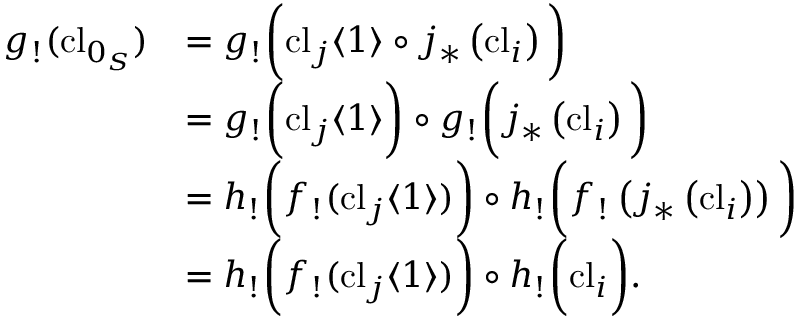Convert formula to latex. <formula><loc_0><loc_0><loc_500><loc_500>\begin{array} { r l } { g _ { ! } ( c l _ { 0 _ { S } } ) } & { = g _ { ! } \left ( c l _ { j } \langle 1 \rangle \circ j _ { * } \left ( c l _ { i } \right ) \right ) } \\ & { = g _ { ! } \left ( c l _ { j } \langle 1 \rangle \right ) \circ g _ { ! } \left ( j _ { * } \left ( c l _ { i } \right ) \right ) } \\ & { = h _ { ! } \left ( f _ { ! } ( c l _ { j } \langle 1 \rangle ) \right ) \circ h _ { ! } \left ( f _ { ! } \left ( j _ { * } \left ( c l _ { i } \right ) \right ) \right ) } \\ & { = h _ { ! } \left ( f _ { ! } ( c l _ { j } \langle 1 \rangle ) \right ) \circ h _ { ! } \left ( c l _ { i } \right ) . } \end{array}</formula> 